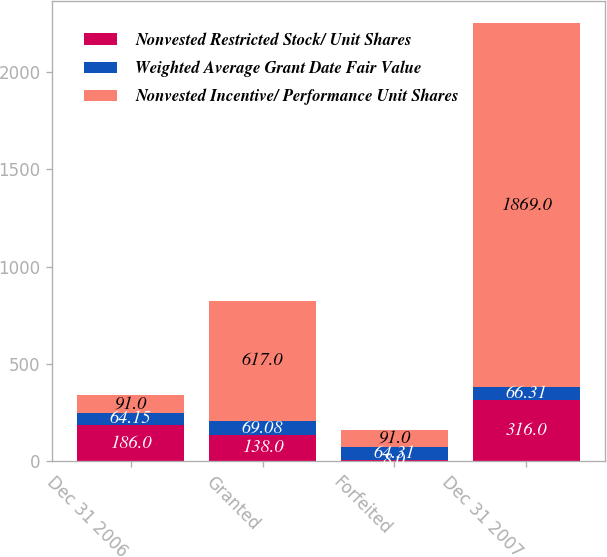Convert chart to OTSL. <chart><loc_0><loc_0><loc_500><loc_500><stacked_bar_chart><ecel><fcel>Dec 31 2006<fcel>Granted<fcel>Forfeited<fcel>Dec 31 2007<nl><fcel>Nonvested Restricted Stock/ Unit Shares<fcel>186<fcel>138<fcel>8<fcel>316<nl><fcel>Weighted Average Grant Date Fair Value<fcel>64.15<fcel>69.08<fcel>64.31<fcel>66.31<nl><fcel>Nonvested Incentive/ Performance Unit Shares<fcel>91<fcel>617<fcel>91<fcel>1869<nl></chart> 